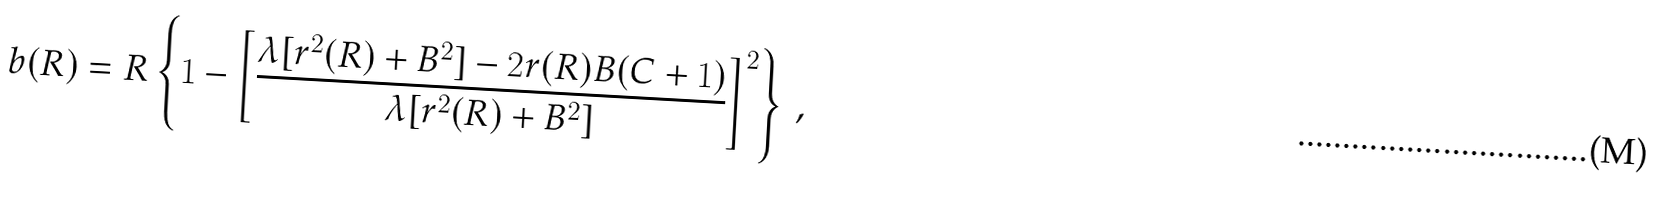Convert formula to latex. <formula><loc_0><loc_0><loc_500><loc_500>b ( R ) = R \left \{ 1 - \left [ \frac { \lambda [ r ^ { 2 } ( R ) + B ^ { 2 } ] - 2 r ( R ) B ( C + 1 ) } { \lambda [ r ^ { 2 } ( R ) + B ^ { 2 } ] } \right ] ^ { 2 } \right \} \, ,</formula> 